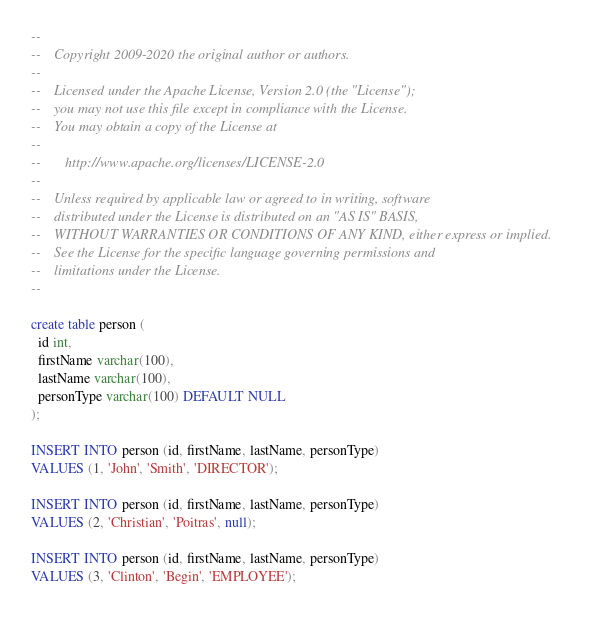Convert code to text. <code><loc_0><loc_0><loc_500><loc_500><_SQL_>--
--    Copyright 2009-2020 the original author or authors.
--
--    Licensed under the Apache License, Version 2.0 (the "License");
--    you may not use this file except in compliance with the License.
--    You may obtain a copy of the License at
--
--       http://www.apache.org/licenses/LICENSE-2.0
--
--    Unless required by applicable law or agreed to in writing, software
--    distributed under the License is distributed on an "AS IS" BASIS,
--    WITHOUT WARRANTIES OR CONDITIONS OF ANY KIND, either express or implied.
--    See the License for the specific language governing permissions and
--    limitations under the License.
--

create table person (
  id int,
  firstName varchar(100),
  lastName varchar(100),
  personType varchar(100) DEFAULT NULL
);

INSERT INTO person (id, firstName, lastName, personType)
VALUES (1, 'John', 'Smith', 'DIRECTOR');

INSERT INTO person (id, firstName, lastName, personType)
VALUES (2, 'Christian', 'Poitras', null);

INSERT INTO person (id, firstName, lastName, personType)
VALUES (3, 'Clinton', 'Begin', 'EMPLOYEE');
</code> 